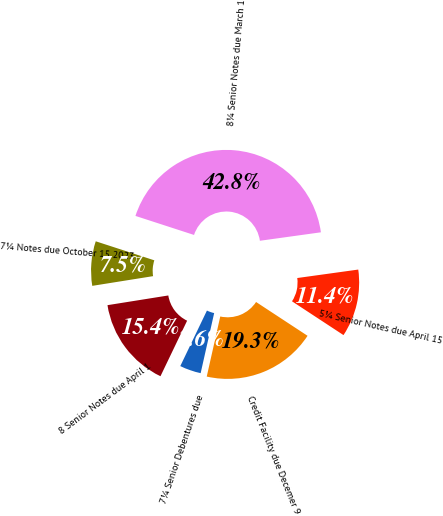<chart> <loc_0><loc_0><loc_500><loc_500><pie_chart><fcel>Credit Facility due Decemer 9<fcel>5¼ Senior Notes due April 15<fcel>8¼ Senior Notes due March 1<fcel>7¼ Notes due October 15 2023<fcel>8 Senior Notes due April 1<fcel>7¼ Senior Debentures due<nl><fcel>19.28%<fcel>11.44%<fcel>42.81%<fcel>7.52%<fcel>15.36%<fcel>3.6%<nl></chart> 